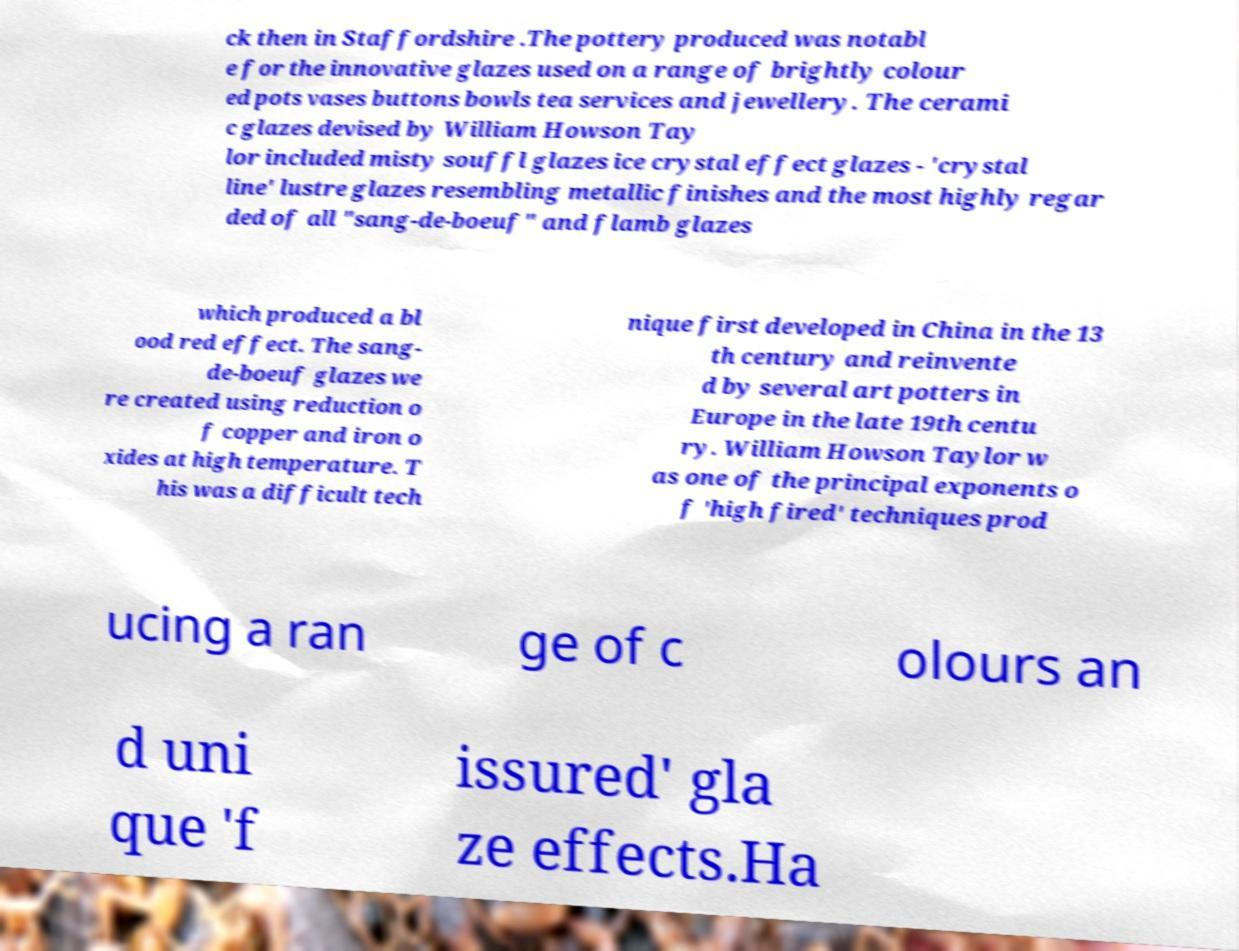There's text embedded in this image that I need extracted. Can you transcribe it verbatim? ck then in Staffordshire .The pottery produced was notabl e for the innovative glazes used on a range of brightly colour ed pots vases buttons bowls tea services and jewellery. The cerami c glazes devised by William Howson Tay lor included misty souffl glazes ice crystal effect glazes - 'crystal line' lustre glazes resembling metallic finishes and the most highly regar ded of all "sang-de-boeuf" and flamb glazes which produced a bl ood red effect. The sang- de-boeuf glazes we re created using reduction o f copper and iron o xides at high temperature. T his was a difficult tech nique first developed in China in the 13 th century and reinvente d by several art potters in Europe in the late 19th centu ry. William Howson Taylor w as one of the principal exponents o f 'high fired' techniques prod ucing a ran ge of c olours an d uni que 'f issured' gla ze effects.Ha 